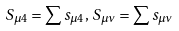<formula> <loc_0><loc_0><loc_500><loc_500>S _ { \mu 4 } = \sum s _ { \mu 4 } , \, S _ { \mu \nu } = \sum s _ { \mu \nu }</formula> 